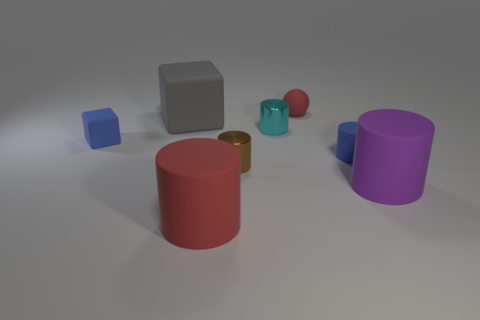What could be the purpose of such an arrangement of shapes? This arrangement might serve educational purposes, such as a teaching aid for understanding geometric shapes, volume, and spatial perception. It could also be part of a visual study in material rendering where lighting and textures are analyzed. Another possibility is that it's a simple compositional exercise for an artist or a 3D modeler testing object placements in a virtual environment. 